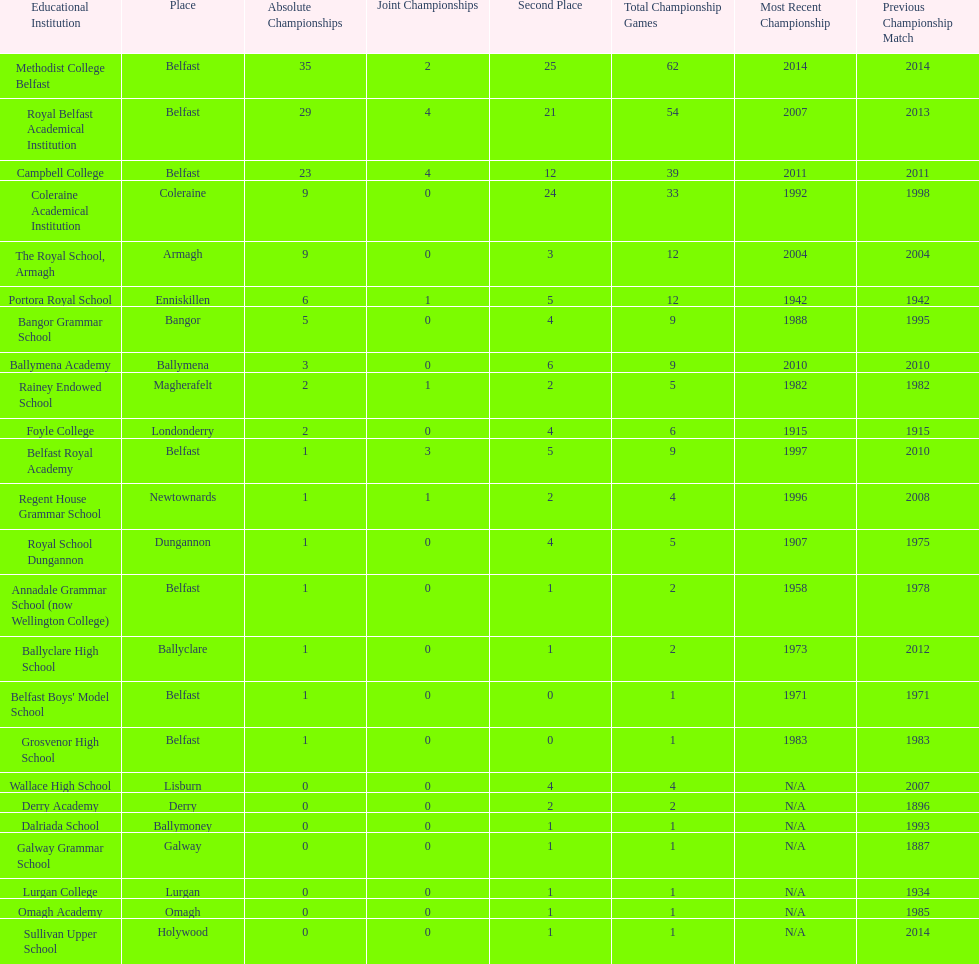Who has the most recent title win, campbell college or regent house grammar school? Campbell College. 